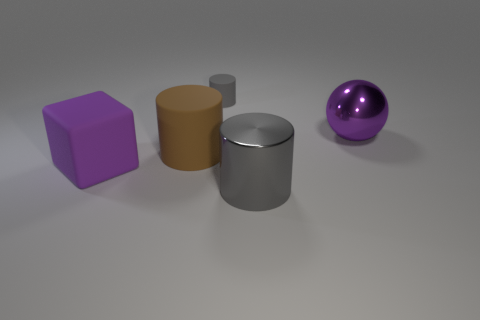Add 1 large spheres. How many objects exist? 6 Subtract all cylinders. How many objects are left? 2 Add 1 rubber cubes. How many rubber cubes are left? 2 Add 3 matte objects. How many matte objects exist? 6 Subtract 1 purple balls. How many objects are left? 4 Subtract all small yellow things. Subtract all brown things. How many objects are left? 4 